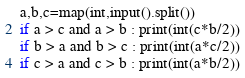<code> <loc_0><loc_0><loc_500><loc_500><_Python_>a,b,c=map(int,input().split())
if a > c and a > b : print(int(c*b/2))
if b > a and b > c : print(int(a*c/2))
if c > a and c > b : print(int(a*b/2))</code> 